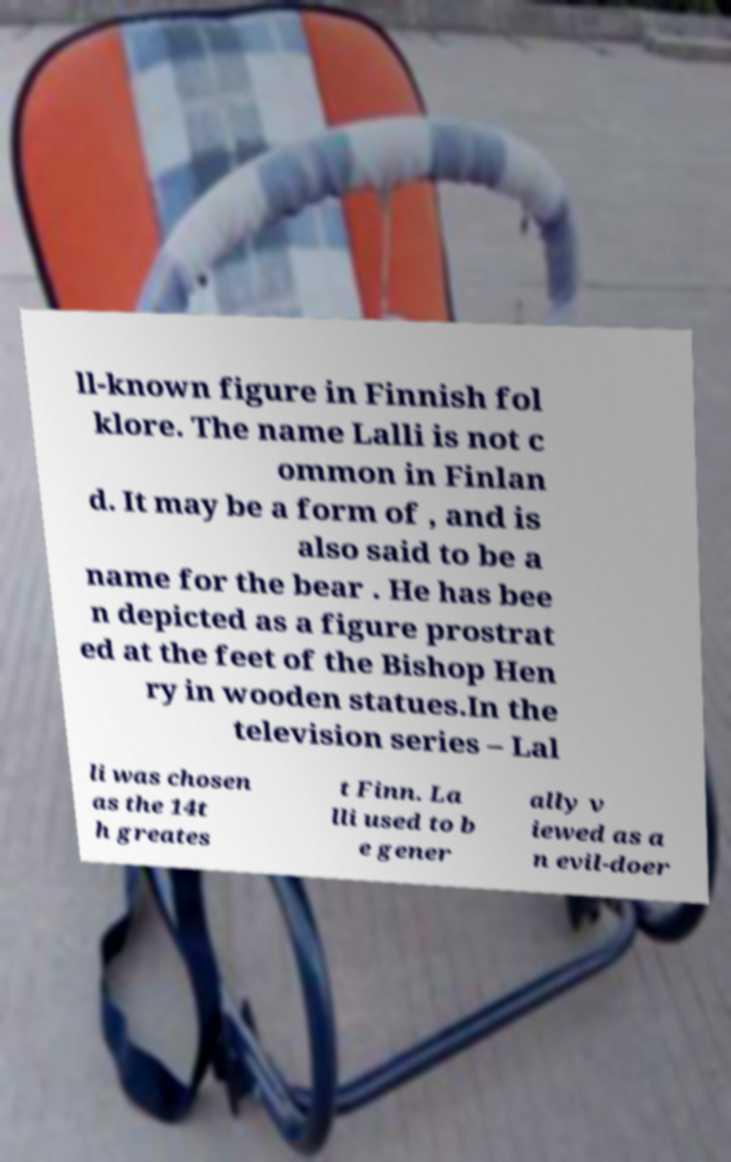Please identify and transcribe the text found in this image. ll-known figure in Finnish fol klore. The name Lalli is not c ommon in Finlan d. It may be a form of , and is also said to be a name for the bear . He has bee n depicted as a figure prostrat ed at the feet of the Bishop Hen ry in wooden statues.In the television series – Lal li was chosen as the 14t h greates t Finn. La lli used to b e gener ally v iewed as a n evil-doer 